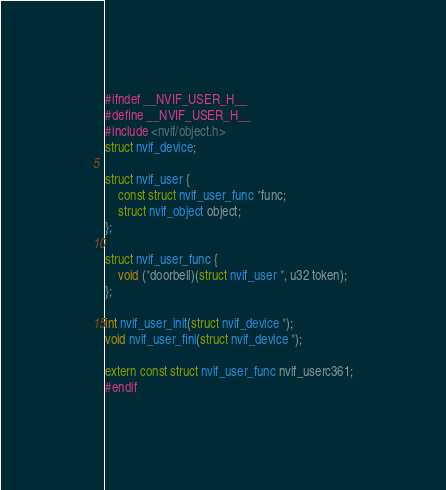Convert code to text. <code><loc_0><loc_0><loc_500><loc_500><_C_>#ifndef __NVIF_USER_H__
#define __NVIF_USER_H__
#include <nvif/object.h>
struct nvif_device;

struct nvif_user {
	const struct nvif_user_func *func;
	struct nvif_object object;
};

struct nvif_user_func {
	void (*doorbell)(struct nvif_user *, u32 token);
};

int nvif_user_init(struct nvif_device *);
void nvif_user_fini(struct nvif_device *);

extern const struct nvif_user_func nvif_userc361;
#endif
</code> 